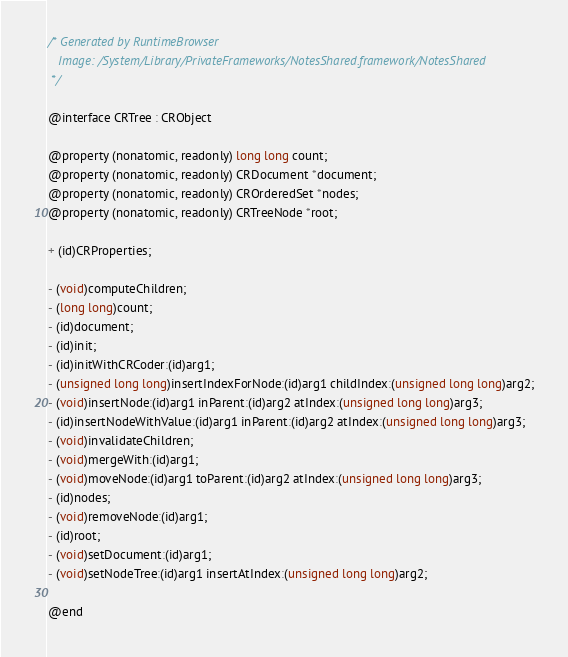Convert code to text. <code><loc_0><loc_0><loc_500><loc_500><_C_>/* Generated by RuntimeBrowser
   Image: /System/Library/PrivateFrameworks/NotesShared.framework/NotesShared
 */

@interface CRTree : CRObject

@property (nonatomic, readonly) long long count;
@property (nonatomic, readonly) CRDocument *document;
@property (nonatomic, readonly) CROrderedSet *nodes;
@property (nonatomic, readonly) CRTreeNode *root;

+ (id)CRProperties;

- (void)computeChildren;
- (long long)count;
- (id)document;
- (id)init;
- (id)initWithCRCoder:(id)arg1;
- (unsigned long long)insertIndexForNode:(id)arg1 childIndex:(unsigned long long)arg2;
- (void)insertNode:(id)arg1 inParent:(id)arg2 atIndex:(unsigned long long)arg3;
- (id)insertNodeWithValue:(id)arg1 inParent:(id)arg2 atIndex:(unsigned long long)arg3;
- (void)invalidateChildren;
- (void)mergeWith:(id)arg1;
- (void)moveNode:(id)arg1 toParent:(id)arg2 atIndex:(unsigned long long)arg3;
- (id)nodes;
- (void)removeNode:(id)arg1;
- (id)root;
- (void)setDocument:(id)arg1;
- (void)setNodeTree:(id)arg1 insertAtIndex:(unsigned long long)arg2;

@end
</code> 